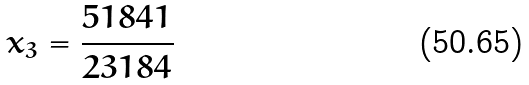Convert formula to latex. <formula><loc_0><loc_0><loc_500><loc_500>x _ { 3 } = \frac { 5 1 8 4 1 } { 2 3 1 8 4 }</formula> 